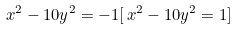<formula> <loc_0><loc_0><loc_500><loc_500>x ^ { 2 } - 1 0 y ^ { 2 } = - 1 [ \, x ^ { 2 } - 1 0 y ^ { 2 } = 1 ]</formula> 